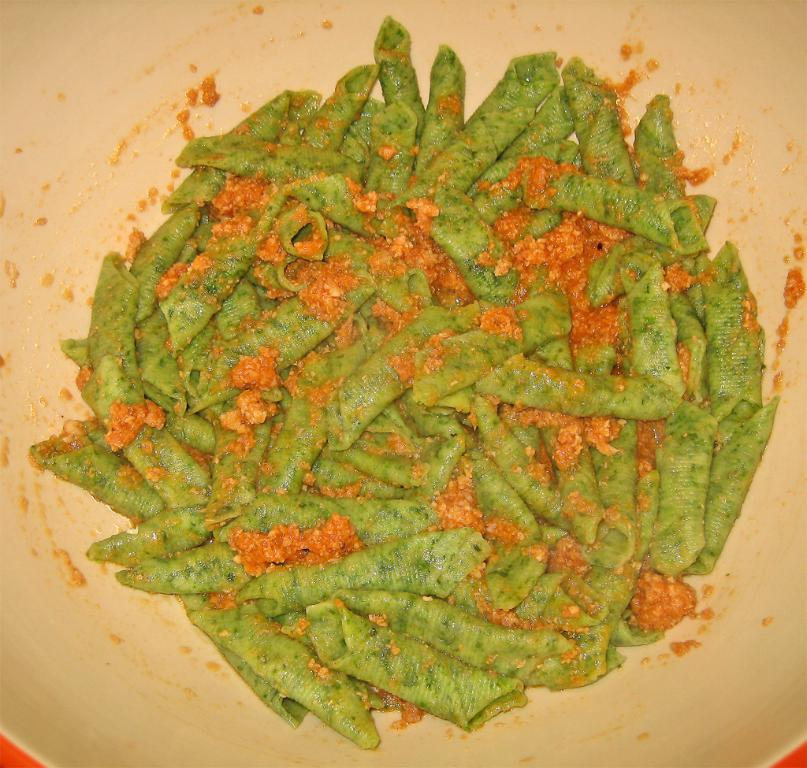What is present in the image? There is food in the image. What is the color of the surface on which the food is placed? The food is on a white surface. Is there a lock on the food in the image? No, there is no lock present on the food in the image. 